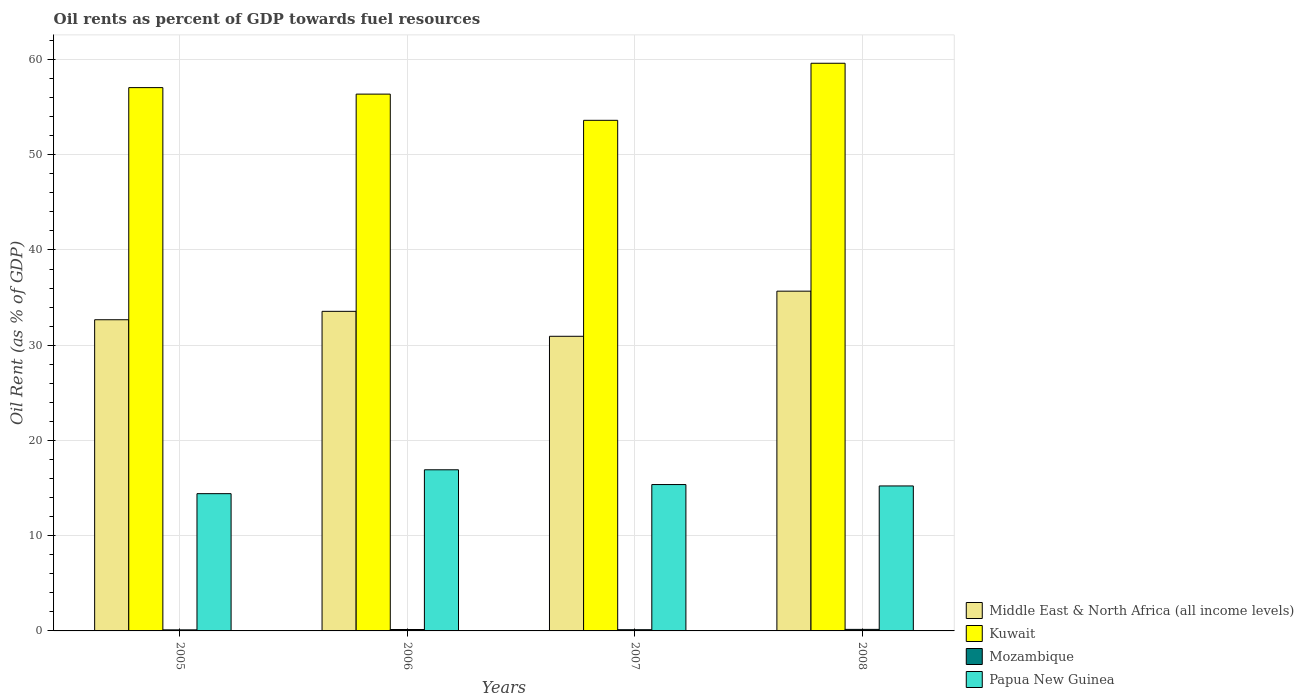How many different coloured bars are there?
Provide a succinct answer. 4. Are the number of bars per tick equal to the number of legend labels?
Provide a short and direct response. Yes. Are the number of bars on each tick of the X-axis equal?
Offer a very short reply. Yes. How many bars are there on the 1st tick from the left?
Give a very brief answer. 4. What is the label of the 3rd group of bars from the left?
Your response must be concise. 2007. What is the oil rent in Mozambique in 2008?
Your answer should be compact. 0.16. Across all years, what is the maximum oil rent in Mozambique?
Your response must be concise. 0.16. Across all years, what is the minimum oil rent in Mozambique?
Make the answer very short. 0.11. In which year was the oil rent in Kuwait maximum?
Offer a terse response. 2008. What is the total oil rent in Middle East & North Africa (all income levels) in the graph?
Your answer should be compact. 132.84. What is the difference between the oil rent in Papua New Guinea in 2007 and that in 2008?
Your answer should be very brief. 0.15. What is the difference between the oil rent in Papua New Guinea in 2007 and the oil rent in Kuwait in 2005?
Give a very brief answer. -41.68. What is the average oil rent in Middle East & North Africa (all income levels) per year?
Make the answer very short. 33.21. In the year 2007, what is the difference between the oil rent in Middle East & North Africa (all income levels) and oil rent in Papua New Guinea?
Offer a terse response. 15.57. In how many years, is the oil rent in Middle East & North Africa (all income levels) greater than 42 %?
Your response must be concise. 0. What is the ratio of the oil rent in Papua New Guinea in 2005 to that in 2007?
Give a very brief answer. 0.94. Is the oil rent in Kuwait in 2006 less than that in 2007?
Give a very brief answer. No. Is the difference between the oil rent in Middle East & North Africa (all income levels) in 2005 and 2007 greater than the difference between the oil rent in Papua New Guinea in 2005 and 2007?
Provide a short and direct response. Yes. What is the difference between the highest and the second highest oil rent in Papua New Guinea?
Offer a very short reply. 1.55. What is the difference between the highest and the lowest oil rent in Kuwait?
Ensure brevity in your answer.  5.99. In how many years, is the oil rent in Middle East & North Africa (all income levels) greater than the average oil rent in Middle East & North Africa (all income levels) taken over all years?
Provide a succinct answer. 2. Is it the case that in every year, the sum of the oil rent in Papua New Guinea and oil rent in Mozambique is greater than the sum of oil rent in Kuwait and oil rent in Middle East & North Africa (all income levels)?
Your answer should be compact. No. What does the 2nd bar from the left in 2005 represents?
Offer a very short reply. Kuwait. What does the 1st bar from the right in 2006 represents?
Provide a succinct answer. Papua New Guinea. How many years are there in the graph?
Your answer should be compact. 4. Are the values on the major ticks of Y-axis written in scientific E-notation?
Provide a succinct answer. No. Does the graph contain any zero values?
Your answer should be very brief. No. Does the graph contain grids?
Provide a succinct answer. Yes. How are the legend labels stacked?
Provide a short and direct response. Vertical. What is the title of the graph?
Provide a succinct answer. Oil rents as percent of GDP towards fuel resources. What is the label or title of the Y-axis?
Give a very brief answer. Oil Rent (as % of GDP). What is the Oil Rent (as % of GDP) in Middle East & North Africa (all income levels) in 2005?
Give a very brief answer. 32.67. What is the Oil Rent (as % of GDP) in Kuwait in 2005?
Your answer should be compact. 57.05. What is the Oil Rent (as % of GDP) in Mozambique in 2005?
Your response must be concise. 0.11. What is the Oil Rent (as % of GDP) of Papua New Guinea in 2005?
Ensure brevity in your answer.  14.41. What is the Oil Rent (as % of GDP) of Middle East & North Africa (all income levels) in 2006?
Offer a very short reply. 33.56. What is the Oil Rent (as % of GDP) in Kuwait in 2006?
Make the answer very short. 56.37. What is the Oil Rent (as % of GDP) in Mozambique in 2006?
Your answer should be very brief. 0.15. What is the Oil Rent (as % of GDP) of Papua New Guinea in 2006?
Give a very brief answer. 16.92. What is the Oil Rent (as % of GDP) of Middle East & North Africa (all income levels) in 2007?
Provide a short and direct response. 30.94. What is the Oil Rent (as % of GDP) in Kuwait in 2007?
Your response must be concise. 53.61. What is the Oil Rent (as % of GDP) of Mozambique in 2007?
Offer a terse response. 0.13. What is the Oil Rent (as % of GDP) in Papua New Guinea in 2007?
Give a very brief answer. 15.37. What is the Oil Rent (as % of GDP) in Middle East & North Africa (all income levels) in 2008?
Give a very brief answer. 35.68. What is the Oil Rent (as % of GDP) in Kuwait in 2008?
Your response must be concise. 59.61. What is the Oil Rent (as % of GDP) in Mozambique in 2008?
Your response must be concise. 0.16. What is the Oil Rent (as % of GDP) of Papua New Guinea in 2008?
Your answer should be very brief. 15.22. Across all years, what is the maximum Oil Rent (as % of GDP) of Middle East & North Africa (all income levels)?
Provide a succinct answer. 35.68. Across all years, what is the maximum Oil Rent (as % of GDP) of Kuwait?
Your answer should be very brief. 59.61. Across all years, what is the maximum Oil Rent (as % of GDP) of Mozambique?
Give a very brief answer. 0.16. Across all years, what is the maximum Oil Rent (as % of GDP) in Papua New Guinea?
Give a very brief answer. 16.92. Across all years, what is the minimum Oil Rent (as % of GDP) of Middle East & North Africa (all income levels)?
Ensure brevity in your answer.  30.94. Across all years, what is the minimum Oil Rent (as % of GDP) of Kuwait?
Your answer should be compact. 53.61. Across all years, what is the minimum Oil Rent (as % of GDP) of Mozambique?
Your answer should be very brief. 0.11. Across all years, what is the minimum Oil Rent (as % of GDP) in Papua New Guinea?
Ensure brevity in your answer.  14.41. What is the total Oil Rent (as % of GDP) in Middle East & North Africa (all income levels) in the graph?
Your response must be concise. 132.84. What is the total Oil Rent (as % of GDP) of Kuwait in the graph?
Provide a short and direct response. 226.63. What is the total Oil Rent (as % of GDP) of Mozambique in the graph?
Keep it short and to the point. 0.55. What is the total Oil Rent (as % of GDP) of Papua New Guinea in the graph?
Your response must be concise. 61.92. What is the difference between the Oil Rent (as % of GDP) of Middle East & North Africa (all income levels) in 2005 and that in 2006?
Your answer should be compact. -0.88. What is the difference between the Oil Rent (as % of GDP) of Kuwait in 2005 and that in 2006?
Provide a succinct answer. 0.68. What is the difference between the Oil Rent (as % of GDP) in Mozambique in 2005 and that in 2006?
Offer a very short reply. -0.04. What is the difference between the Oil Rent (as % of GDP) in Papua New Guinea in 2005 and that in 2006?
Your response must be concise. -2.51. What is the difference between the Oil Rent (as % of GDP) in Middle East & North Africa (all income levels) in 2005 and that in 2007?
Give a very brief answer. 1.74. What is the difference between the Oil Rent (as % of GDP) in Kuwait in 2005 and that in 2007?
Offer a very short reply. 3.44. What is the difference between the Oil Rent (as % of GDP) in Mozambique in 2005 and that in 2007?
Provide a succinct answer. -0.02. What is the difference between the Oil Rent (as % of GDP) of Papua New Guinea in 2005 and that in 2007?
Your answer should be very brief. -0.96. What is the difference between the Oil Rent (as % of GDP) of Middle East & North Africa (all income levels) in 2005 and that in 2008?
Give a very brief answer. -3. What is the difference between the Oil Rent (as % of GDP) in Kuwait in 2005 and that in 2008?
Provide a succinct answer. -2.56. What is the difference between the Oil Rent (as % of GDP) in Mozambique in 2005 and that in 2008?
Offer a terse response. -0.05. What is the difference between the Oil Rent (as % of GDP) of Papua New Guinea in 2005 and that in 2008?
Your response must be concise. -0.81. What is the difference between the Oil Rent (as % of GDP) in Middle East & North Africa (all income levels) in 2006 and that in 2007?
Your answer should be compact. 2.62. What is the difference between the Oil Rent (as % of GDP) in Kuwait in 2006 and that in 2007?
Ensure brevity in your answer.  2.75. What is the difference between the Oil Rent (as % of GDP) in Mozambique in 2006 and that in 2007?
Make the answer very short. 0.02. What is the difference between the Oil Rent (as % of GDP) of Papua New Guinea in 2006 and that in 2007?
Your answer should be very brief. 1.55. What is the difference between the Oil Rent (as % of GDP) of Middle East & North Africa (all income levels) in 2006 and that in 2008?
Provide a succinct answer. -2.12. What is the difference between the Oil Rent (as % of GDP) in Kuwait in 2006 and that in 2008?
Give a very brief answer. -3.24. What is the difference between the Oil Rent (as % of GDP) of Mozambique in 2006 and that in 2008?
Offer a terse response. -0.01. What is the difference between the Oil Rent (as % of GDP) in Papua New Guinea in 2006 and that in 2008?
Your response must be concise. 1.7. What is the difference between the Oil Rent (as % of GDP) of Middle East & North Africa (all income levels) in 2007 and that in 2008?
Provide a succinct answer. -4.74. What is the difference between the Oil Rent (as % of GDP) in Kuwait in 2007 and that in 2008?
Offer a very short reply. -5.99. What is the difference between the Oil Rent (as % of GDP) of Mozambique in 2007 and that in 2008?
Ensure brevity in your answer.  -0.03. What is the difference between the Oil Rent (as % of GDP) in Papua New Guinea in 2007 and that in 2008?
Provide a short and direct response. 0.15. What is the difference between the Oil Rent (as % of GDP) of Middle East & North Africa (all income levels) in 2005 and the Oil Rent (as % of GDP) of Kuwait in 2006?
Make the answer very short. -23.69. What is the difference between the Oil Rent (as % of GDP) of Middle East & North Africa (all income levels) in 2005 and the Oil Rent (as % of GDP) of Mozambique in 2006?
Provide a short and direct response. 32.53. What is the difference between the Oil Rent (as % of GDP) of Middle East & North Africa (all income levels) in 2005 and the Oil Rent (as % of GDP) of Papua New Guinea in 2006?
Make the answer very short. 15.76. What is the difference between the Oil Rent (as % of GDP) of Kuwait in 2005 and the Oil Rent (as % of GDP) of Mozambique in 2006?
Make the answer very short. 56.9. What is the difference between the Oil Rent (as % of GDP) in Kuwait in 2005 and the Oil Rent (as % of GDP) in Papua New Guinea in 2006?
Offer a very short reply. 40.13. What is the difference between the Oil Rent (as % of GDP) of Mozambique in 2005 and the Oil Rent (as % of GDP) of Papua New Guinea in 2006?
Keep it short and to the point. -16.81. What is the difference between the Oil Rent (as % of GDP) of Middle East & North Africa (all income levels) in 2005 and the Oil Rent (as % of GDP) of Kuwait in 2007?
Your answer should be compact. -20.94. What is the difference between the Oil Rent (as % of GDP) in Middle East & North Africa (all income levels) in 2005 and the Oil Rent (as % of GDP) in Mozambique in 2007?
Provide a short and direct response. 32.55. What is the difference between the Oil Rent (as % of GDP) of Middle East & North Africa (all income levels) in 2005 and the Oil Rent (as % of GDP) of Papua New Guinea in 2007?
Provide a succinct answer. 17.31. What is the difference between the Oil Rent (as % of GDP) in Kuwait in 2005 and the Oil Rent (as % of GDP) in Mozambique in 2007?
Provide a short and direct response. 56.92. What is the difference between the Oil Rent (as % of GDP) in Kuwait in 2005 and the Oil Rent (as % of GDP) in Papua New Guinea in 2007?
Your answer should be very brief. 41.68. What is the difference between the Oil Rent (as % of GDP) in Mozambique in 2005 and the Oil Rent (as % of GDP) in Papua New Guinea in 2007?
Offer a very short reply. -15.26. What is the difference between the Oil Rent (as % of GDP) in Middle East & North Africa (all income levels) in 2005 and the Oil Rent (as % of GDP) in Kuwait in 2008?
Offer a very short reply. -26.93. What is the difference between the Oil Rent (as % of GDP) of Middle East & North Africa (all income levels) in 2005 and the Oil Rent (as % of GDP) of Mozambique in 2008?
Provide a succinct answer. 32.51. What is the difference between the Oil Rent (as % of GDP) of Middle East & North Africa (all income levels) in 2005 and the Oil Rent (as % of GDP) of Papua New Guinea in 2008?
Provide a short and direct response. 17.45. What is the difference between the Oil Rent (as % of GDP) of Kuwait in 2005 and the Oil Rent (as % of GDP) of Mozambique in 2008?
Ensure brevity in your answer.  56.89. What is the difference between the Oil Rent (as % of GDP) of Kuwait in 2005 and the Oil Rent (as % of GDP) of Papua New Guinea in 2008?
Provide a short and direct response. 41.83. What is the difference between the Oil Rent (as % of GDP) in Mozambique in 2005 and the Oil Rent (as % of GDP) in Papua New Guinea in 2008?
Offer a very short reply. -15.11. What is the difference between the Oil Rent (as % of GDP) of Middle East & North Africa (all income levels) in 2006 and the Oil Rent (as % of GDP) of Kuwait in 2007?
Offer a terse response. -20.06. What is the difference between the Oil Rent (as % of GDP) in Middle East & North Africa (all income levels) in 2006 and the Oil Rent (as % of GDP) in Mozambique in 2007?
Your answer should be very brief. 33.43. What is the difference between the Oil Rent (as % of GDP) in Middle East & North Africa (all income levels) in 2006 and the Oil Rent (as % of GDP) in Papua New Guinea in 2007?
Offer a very short reply. 18.19. What is the difference between the Oil Rent (as % of GDP) in Kuwait in 2006 and the Oil Rent (as % of GDP) in Mozambique in 2007?
Provide a succinct answer. 56.24. What is the difference between the Oil Rent (as % of GDP) in Kuwait in 2006 and the Oil Rent (as % of GDP) in Papua New Guinea in 2007?
Give a very brief answer. 41. What is the difference between the Oil Rent (as % of GDP) in Mozambique in 2006 and the Oil Rent (as % of GDP) in Papua New Guinea in 2007?
Provide a short and direct response. -15.22. What is the difference between the Oil Rent (as % of GDP) in Middle East & North Africa (all income levels) in 2006 and the Oil Rent (as % of GDP) in Kuwait in 2008?
Ensure brevity in your answer.  -26.05. What is the difference between the Oil Rent (as % of GDP) of Middle East & North Africa (all income levels) in 2006 and the Oil Rent (as % of GDP) of Mozambique in 2008?
Provide a succinct answer. 33.4. What is the difference between the Oil Rent (as % of GDP) of Middle East & North Africa (all income levels) in 2006 and the Oil Rent (as % of GDP) of Papua New Guinea in 2008?
Your answer should be compact. 18.34. What is the difference between the Oil Rent (as % of GDP) of Kuwait in 2006 and the Oil Rent (as % of GDP) of Mozambique in 2008?
Keep it short and to the point. 56.2. What is the difference between the Oil Rent (as % of GDP) in Kuwait in 2006 and the Oil Rent (as % of GDP) in Papua New Guinea in 2008?
Your answer should be compact. 41.14. What is the difference between the Oil Rent (as % of GDP) of Mozambique in 2006 and the Oil Rent (as % of GDP) of Papua New Guinea in 2008?
Give a very brief answer. -15.07. What is the difference between the Oil Rent (as % of GDP) in Middle East & North Africa (all income levels) in 2007 and the Oil Rent (as % of GDP) in Kuwait in 2008?
Give a very brief answer. -28.67. What is the difference between the Oil Rent (as % of GDP) in Middle East & North Africa (all income levels) in 2007 and the Oil Rent (as % of GDP) in Mozambique in 2008?
Keep it short and to the point. 30.78. What is the difference between the Oil Rent (as % of GDP) of Middle East & North Africa (all income levels) in 2007 and the Oil Rent (as % of GDP) of Papua New Guinea in 2008?
Keep it short and to the point. 15.71. What is the difference between the Oil Rent (as % of GDP) of Kuwait in 2007 and the Oil Rent (as % of GDP) of Mozambique in 2008?
Give a very brief answer. 53.45. What is the difference between the Oil Rent (as % of GDP) in Kuwait in 2007 and the Oil Rent (as % of GDP) in Papua New Guinea in 2008?
Provide a succinct answer. 38.39. What is the difference between the Oil Rent (as % of GDP) of Mozambique in 2007 and the Oil Rent (as % of GDP) of Papua New Guinea in 2008?
Provide a succinct answer. -15.1. What is the average Oil Rent (as % of GDP) in Middle East & North Africa (all income levels) per year?
Your response must be concise. 33.21. What is the average Oil Rent (as % of GDP) in Kuwait per year?
Make the answer very short. 56.66. What is the average Oil Rent (as % of GDP) of Mozambique per year?
Make the answer very short. 0.14. What is the average Oil Rent (as % of GDP) of Papua New Guinea per year?
Provide a short and direct response. 15.48. In the year 2005, what is the difference between the Oil Rent (as % of GDP) in Middle East & North Africa (all income levels) and Oil Rent (as % of GDP) in Kuwait?
Ensure brevity in your answer.  -24.37. In the year 2005, what is the difference between the Oil Rent (as % of GDP) of Middle East & North Africa (all income levels) and Oil Rent (as % of GDP) of Mozambique?
Provide a succinct answer. 32.56. In the year 2005, what is the difference between the Oil Rent (as % of GDP) of Middle East & North Africa (all income levels) and Oil Rent (as % of GDP) of Papua New Guinea?
Provide a succinct answer. 18.26. In the year 2005, what is the difference between the Oil Rent (as % of GDP) of Kuwait and Oil Rent (as % of GDP) of Mozambique?
Keep it short and to the point. 56.94. In the year 2005, what is the difference between the Oil Rent (as % of GDP) in Kuwait and Oil Rent (as % of GDP) in Papua New Guinea?
Your answer should be compact. 42.64. In the year 2005, what is the difference between the Oil Rent (as % of GDP) of Mozambique and Oil Rent (as % of GDP) of Papua New Guinea?
Offer a very short reply. -14.3. In the year 2006, what is the difference between the Oil Rent (as % of GDP) of Middle East & North Africa (all income levels) and Oil Rent (as % of GDP) of Kuwait?
Provide a short and direct response. -22.81. In the year 2006, what is the difference between the Oil Rent (as % of GDP) in Middle East & North Africa (all income levels) and Oil Rent (as % of GDP) in Mozambique?
Your answer should be compact. 33.41. In the year 2006, what is the difference between the Oil Rent (as % of GDP) in Middle East & North Africa (all income levels) and Oil Rent (as % of GDP) in Papua New Guinea?
Your answer should be compact. 16.64. In the year 2006, what is the difference between the Oil Rent (as % of GDP) in Kuwait and Oil Rent (as % of GDP) in Mozambique?
Provide a short and direct response. 56.22. In the year 2006, what is the difference between the Oil Rent (as % of GDP) of Kuwait and Oil Rent (as % of GDP) of Papua New Guinea?
Make the answer very short. 39.45. In the year 2006, what is the difference between the Oil Rent (as % of GDP) of Mozambique and Oil Rent (as % of GDP) of Papua New Guinea?
Provide a short and direct response. -16.77. In the year 2007, what is the difference between the Oil Rent (as % of GDP) in Middle East & North Africa (all income levels) and Oil Rent (as % of GDP) in Kuwait?
Keep it short and to the point. -22.68. In the year 2007, what is the difference between the Oil Rent (as % of GDP) in Middle East & North Africa (all income levels) and Oil Rent (as % of GDP) in Mozambique?
Ensure brevity in your answer.  30.81. In the year 2007, what is the difference between the Oil Rent (as % of GDP) of Middle East & North Africa (all income levels) and Oil Rent (as % of GDP) of Papua New Guinea?
Keep it short and to the point. 15.57. In the year 2007, what is the difference between the Oil Rent (as % of GDP) of Kuwait and Oil Rent (as % of GDP) of Mozambique?
Keep it short and to the point. 53.49. In the year 2007, what is the difference between the Oil Rent (as % of GDP) of Kuwait and Oil Rent (as % of GDP) of Papua New Guinea?
Ensure brevity in your answer.  38.25. In the year 2007, what is the difference between the Oil Rent (as % of GDP) in Mozambique and Oil Rent (as % of GDP) in Papua New Guinea?
Provide a short and direct response. -15.24. In the year 2008, what is the difference between the Oil Rent (as % of GDP) of Middle East & North Africa (all income levels) and Oil Rent (as % of GDP) of Kuwait?
Give a very brief answer. -23.93. In the year 2008, what is the difference between the Oil Rent (as % of GDP) of Middle East & North Africa (all income levels) and Oil Rent (as % of GDP) of Mozambique?
Your answer should be compact. 35.51. In the year 2008, what is the difference between the Oil Rent (as % of GDP) of Middle East & North Africa (all income levels) and Oil Rent (as % of GDP) of Papua New Guinea?
Offer a terse response. 20.45. In the year 2008, what is the difference between the Oil Rent (as % of GDP) of Kuwait and Oil Rent (as % of GDP) of Mozambique?
Provide a succinct answer. 59.45. In the year 2008, what is the difference between the Oil Rent (as % of GDP) of Kuwait and Oil Rent (as % of GDP) of Papua New Guinea?
Offer a very short reply. 44.38. In the year 2008, what is the difference between the Oil Rent (as % of GDP) of Mozambique and Oil Rent (as % of GDP) of Papua New Guinea?
Your response must be concise. -15.06. What is the ratio of the Oil Rent (as % of GDP) in Middle East & North Africa (all income levels) in 2005 to that in 2006?
Make the answer very short. 0.97. What is the ratio of the Oil Rent (as % of GDP) in Kuwait in 2005 to that in 2006?
Provide a succinct answer. 1.01. What is the ratio of the Oil Rent (as % of GDP) of Mozambique in 2005 to that in 2006?
Your response must be concise. 0.75. What is the ratio of the Oil Rent (as % of GDP) of Papua New Guinea in 2005 to that in 2006?
Keep it short and to the point. 0.85. What is the ratio of the Oil Rent (as % of GDP) of Middle East & North Africa (all income levels) in 2005 to that in 2007?
Keep it short and to the point. 1.06. What is the ratio of the Oil Rent (as % of GDP) in Kuwait in 2005 to that in 2007?
Make the answer very short. 1.06. What is the ratio of the Oil Rent (as % of GDP) of Mozambique in 2005 to that in 2007?
Offer a terse response. 0.87. What is the ratio of the Oil Rent (as % of GDP) of Papua New Guinea in 2005 to that in 2007?
Keep it short and to the point. 0.94. What is the ratio of the Oil Rent (as % of GDP) of Middle East & North Africa (all income levels) in 2005 to that in 2008?
Your response must be concise. 0.92. What is the ratio of the Oil Rent (as % of GDP) of Kuwait in 2005 to that in 2008?
Your answer should be very brief. 0.96. What is the ratio of the Oil Rent (as % of GDP) of Mozambique in 2005 to that in 2008?
Offer a terse response. 0.69. What is the ratio of the Oil Rent (as % of GDP) of Papua New Guinea in 2005 to that in 2008?
Ensure brevity in your answer.  0.95. What is the ratio of the Oil Rent (as % of GDP) of Middle East & North Africa (all income levels) in 2006 to that in 2007?
Ensure brevity in your answer.  1.08. What is the ratio of the Oil Rent (as % of GDP) of Kuwait in 2006 to that in 2007?
Your answer should be very brief. 1.05. What is the ratio of the Oil Rent (as % of GDP) of Mozambique in 2006 to that in 2007?
Your response must be concise. 1.17. What is the ratio of the Oil Rent (as % of GDP) in Papua New Guinea in 2006 to that in 2007?
Your answer should be compact. 1.1. What is the ratio of the Oil Rent (as % of GDP) in Middle East & North Africa (all income levels) in 2006 to that in 2008?
Make the answer very short. 0.94. What is the ratio of the Oil Rent (as % of GDP) of Kuwait in 2006 to that in 2008?
Your response must be concise. 0.95. What is the ratio of the Oil Rent (as % of GDP) in Mozambique in 2006 to that in 2008?
Your response must be concise. 0.92. What is the ratio of the Oil Rent (as % of GDP) in Papua New Guinea in 2006 to that in 2008?
Your response must be concise. 1.11. What is the ratio of the Oil Rent (as % of GDP) of Middle East & North Africa (all income levels) in 2007 to that in 2008?
Your response must be concise. 0.87. What is the ratio of the Oil Rent (as % of GDP) of Kuwait in 2007 to that in 2008?
Provide a succinct answer. 0.9. What is the ratio of the Oil Rent (as % of GDP) of Mozambique in 2007 to that in 2008?
Ensure brevity in your answer.  0.79. What is the ratio of the Oil Rent (as % of GDP) of Papua New Guinea in 2007 to that in 2008?
Make the answer very short. 1.01. What is the difference between the highest and the second highest Oil Rent (as % of GDP) of Middle East & North Africa (all income levels)?
Ensure brevity in your answer.  2.12. What is the difference between the highest and the second highest Oil Rent (as % of GDP) in Kuwait?
Make the answer very short. 2.56. What is the difference between the highest and the second highest Oil Rent (as % of GDP) in Mozambique?
Your answer should be very brief. 0.01. What is the difference between the highest and the second highest Oil Rent (as % of GDP) in Papua New Guinea?
Offer a terse response. 1.55. What is the difference between the highest and the lowest Oil Rent (as % of GDP) in Middle East & North Africa (all income levels)?
Offer a very short reply. 4.74. What is the difference between the highest and the lowest Oil Rent (as % of GDP) of Kuwait?
Provide a short and direct response. 5.99. What is the difference between the highest and the lowest Oil Rent (as % of GDP) of Mozambique?
Your response must be concise. 0.05. What is the difference between the highest and the lowest Oil Rent (as % of GDP) in Papua New Guinea?
Your response must be concise. 2.51. 